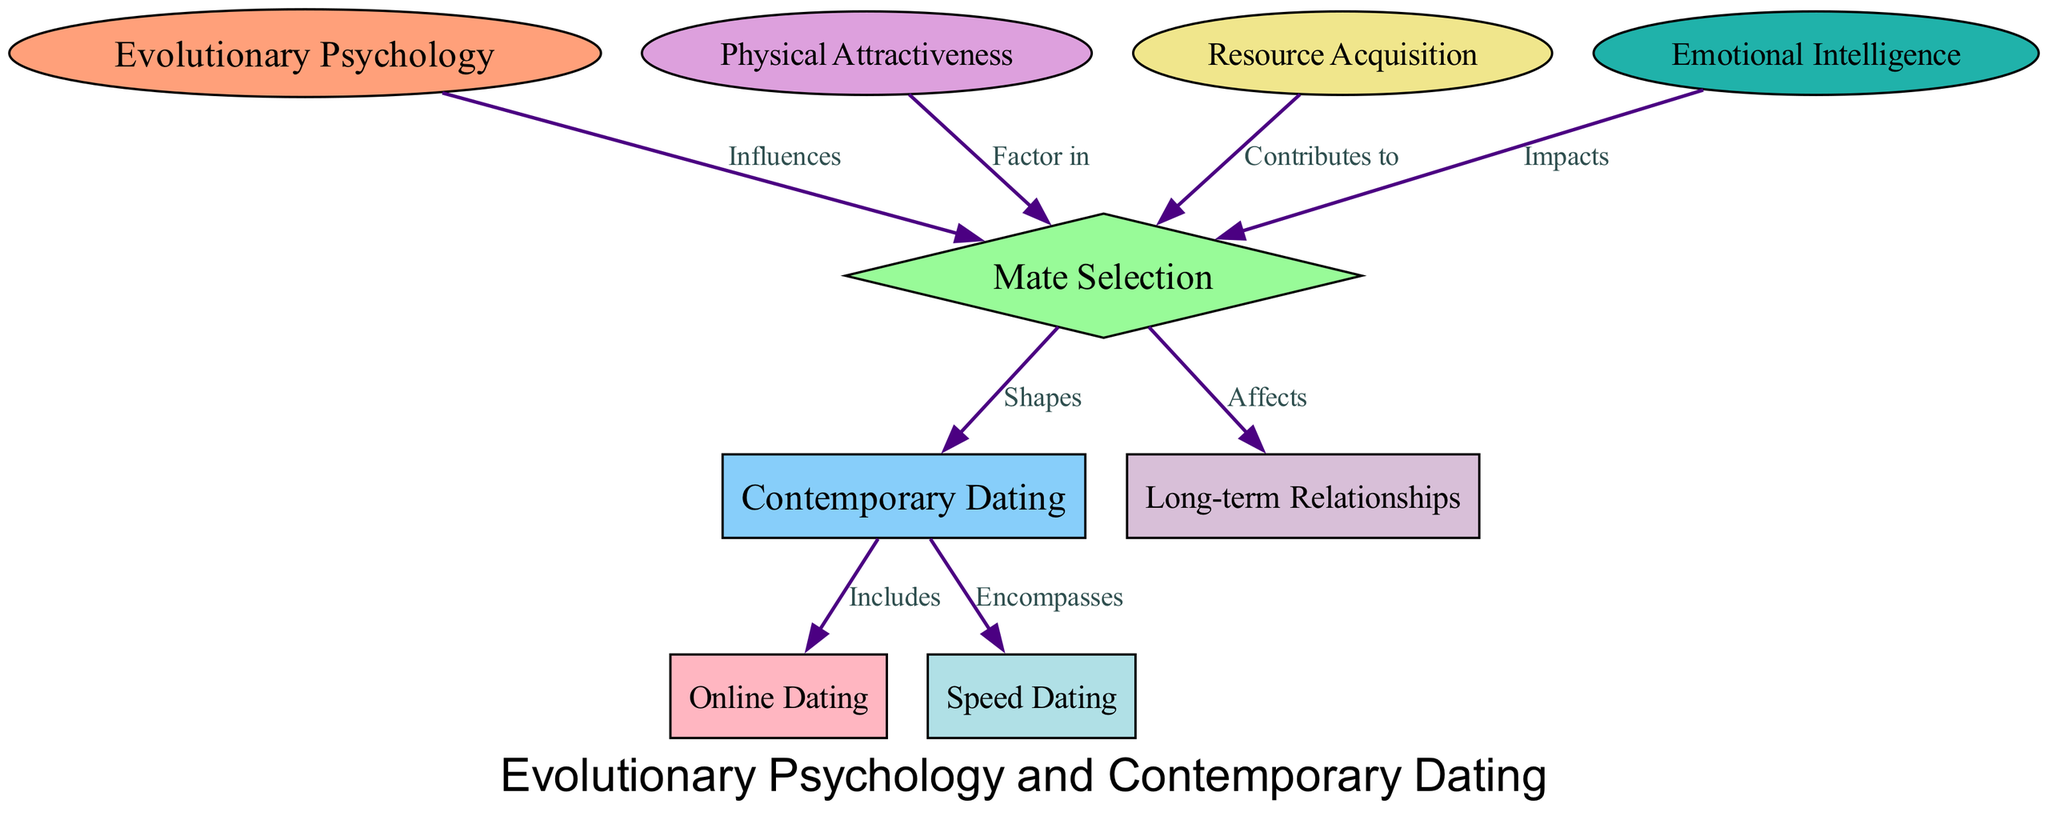What is the primary influence on mate selection shown in the diagram? The diagram indicates that "Evolutionary Psychology" influences "Mate Selection." This is depicted by the directed edge labeled "Influences" connecting node 1 ("Evolutionary Psychology") to node 2 ("Mate Selection").
Answer: Evolutionary Psychology How many nodes are present in the diagram? By counting the nodes listed, there are a total of 9 nodes represented in the diagram.
Answer: 9 What factor contributes to mate selection related to physical characteristics? The diagram specifies that "Physical Attractiveness" is a factor in "Mate Selection," as indicated by the edge labeled "Factor in."
Answer: Physical Attractiveness Which contemporary dating method is included in the diagram? "Online Dating" is explicitly mentioned as part of "Contemporary Dating," as shown by the edge labeled "Includes" that connects node 3 ("Contemporary Dating") to node 7 ("Online Dating").
Answer: Online Dating What is the relationship between mate selection and long-term relationships? The diagram illustrates that "Mate Selection" affects "Long-term Relationships." This relationship is indicated by the edge labeled "Affects" connecting node 2 ("Mate Selection") to node 9 ("Long-term Relationships").
Answer: Affects What contributes to mate selection in terms of resources? According to the diagram, "Resource Acquisition" is shown to contribute to "Mate Selection," which is represented by the edge labeled "Contributes to."
Answer: Resource Acquisition How many directed edges are visible in the diagram? By reviewing the edges listed, there are a total of 8 directed edges connecting various nodes within the diagram.
Answer: 8 Which concept impacts mate selection based on emotional skills? The diagram indicates that "Emotional Intelligence" impacts "Mate Selection," as shown by the edge labeled "Impacts" connecting node 6 to node 2.
Answer: Emotional Intelligence What contemporary dating method encompasses speed dating? "Contemporary Dating" encompasses "Speed Dating," as indicated by the edge labeled "Encompasses" connecting node 3 to node 8.
Answer: Speed Dating 